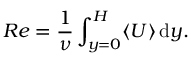<formula> <loc_0><loc_0><loc_500><loc_500>R e = \frac { 1 } { \nu } \int _ { y = 0 } ^ { H } \langle U \rangle \, d y .</formula> 